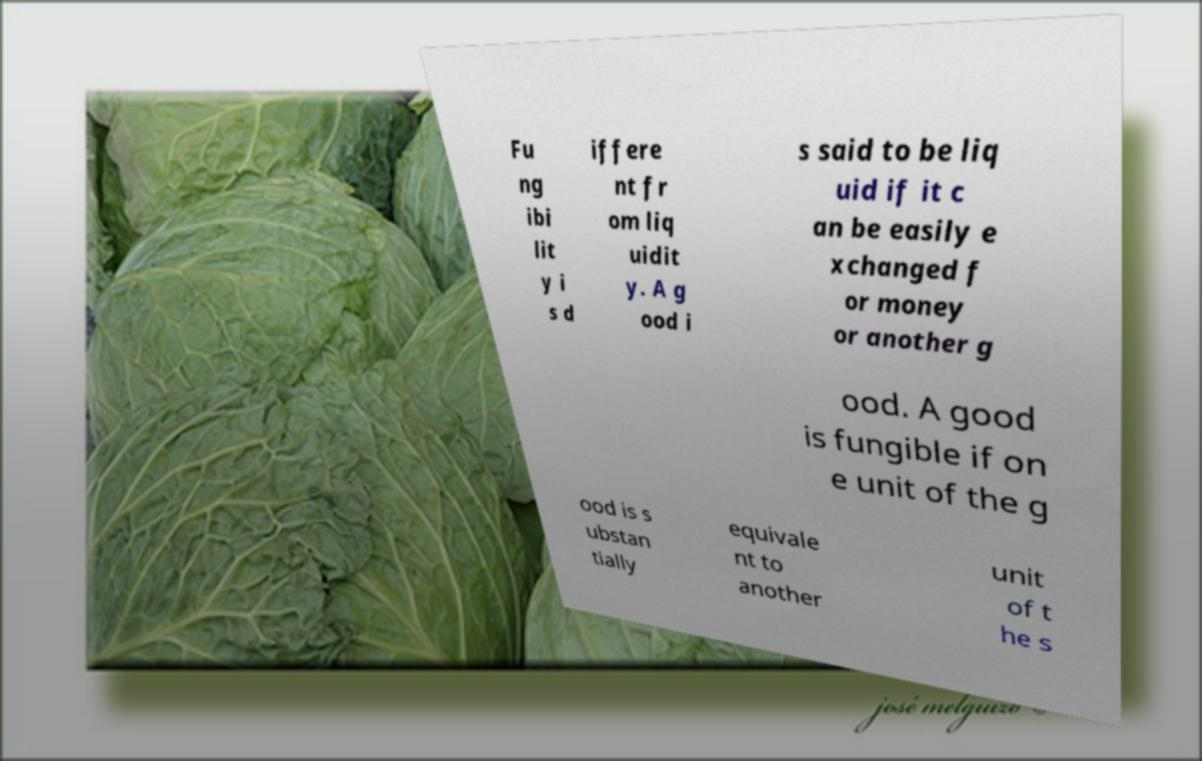There's text embedded in this image that I need extracted. Can you transcribe it verbatim? Fu ng ibi lit y i s d iffere nt fr om liq uidit y. A g ood i s said to be liq uid if it c an be easily e xchanged f or money or another g ood. A good is fungible if on e unit of the g ood is s ubstan tially equivale nt to another unit of t he s 